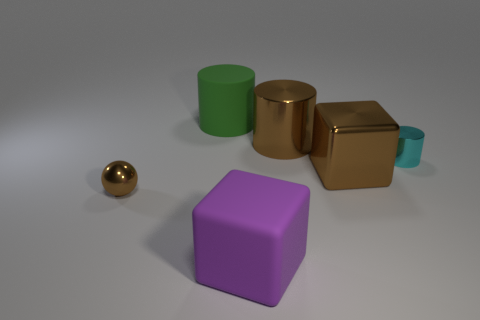Subtract all large cylinders. How many cylinders are left? 1 Add 1 small gray metal objects. How many objects exist? 7 Subtract 1 cylinders. How many cylinders are left? 2 Subtract all brown cylinders. How many cylinders are left? 2 Subtract all gray balls. Subtract all red cylinders. How many balls are left? 1 Subtract all cyan balls. How many cyan cubes are left? 0 Add 1 big purple matte cubes. How many big purple matte cubes are left? 2 Add 5 big gray metal cylinders. How many big gray metal cylinders exist? 5 Subtract 0 cyan blocks. How many objects are left? 6 Subtract all balls. How many objects are left? 5 